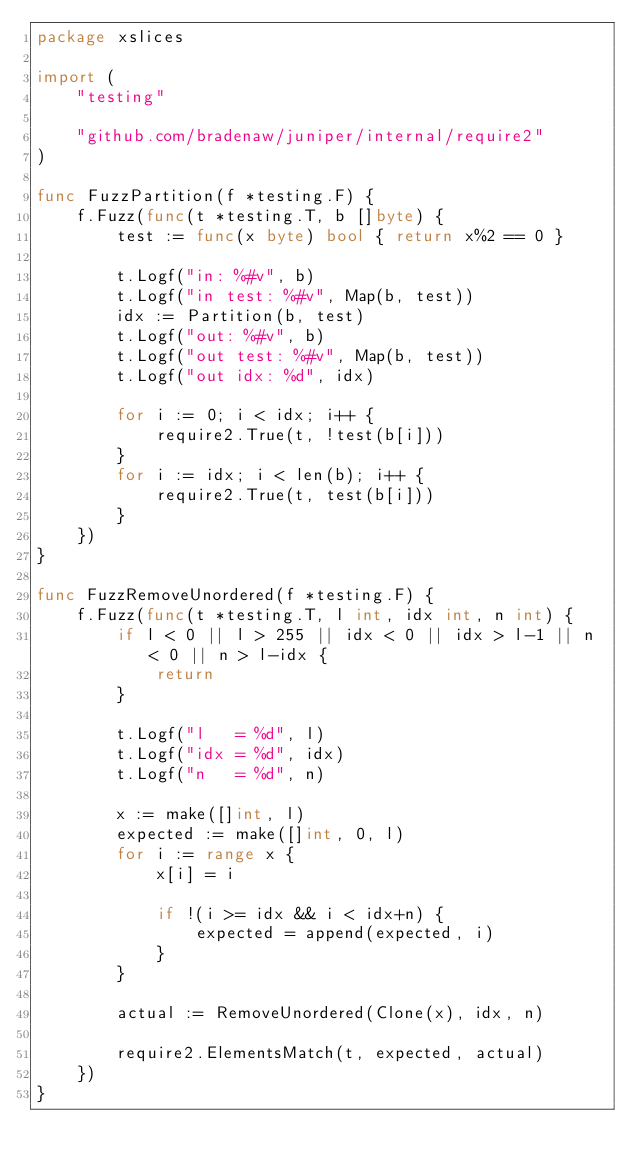<code> <loc_0><loc_0><loc_500><loc_500><_Go_>package xslices

import (
	"testing"

	"github.com/bradenaw/juniper/internal/require2"
)

func FuzzPartition(f *testing.F) {
	f.Fuzz(func(t *testing.T, b []byte) {
		test := func(x byte) bool { return x%2 == 0 }

		t.Logf("in: %#v", b)
		t.Logf("in test: %#v", Map(b, test))
		idx := Partition(b, test)
		t.Logf("out: %#v", b)
		t.Logf("out test: %#v", Map(b, test))
		t.Logf("out idx: %d", idx)

		for i := 0; i < idx; i++ {
			require2.True(t, !test(b[i]))
		}
		for i := idx; i < len(b); i++ {
			require2.True(t, test(b[i]))
		}
	})
}

func FuzzRemoveUnordered(f *testing.F) {
	f.Fuzz(func(t *testing.T, l int, idx int, n int) {
		if l < 0 || l > 255 || idx < 0 || idx > l-1 || n < 0 || n > l-idx {
			return
		}

		t.Logf("l   = %d", l)
		t.Logf("idx = %d", idx)
		t.Logf("n   = %d", n)

		x := make([]int, l)
		expected := make([]int, 0, l)
		for i := range x {
			x[i] = i

			if !(i >= idx && i < idx+n) {
				expected = append(expected, i)
			}
		}

		actual := RemoveUnordered(Clone(x), idx, n)

		require2.ElementsMatch(t, expected, actual)
	})
}
</code> 